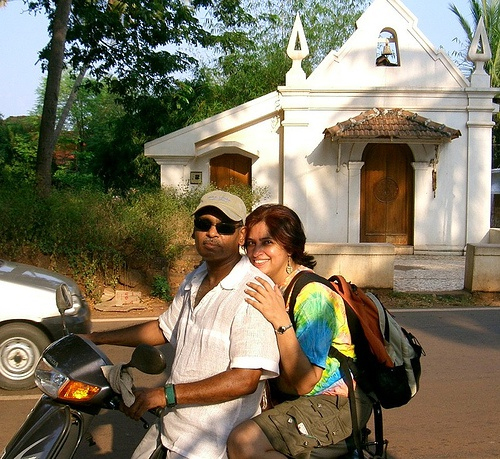Describe the objects in this image and their specific colors. I can see people in gray, ivory, black, maroon, and brown tones, people in gray, black, olive, tan, and maroon tones, motorcycle in gray, black, and maroon tones, car in gray, white, and black tones, and backpack in gray, black, and maroon tones in this image. 